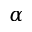<formula> <loc_0><loc_0><loc_500><loc_500>\alpha</formula> 